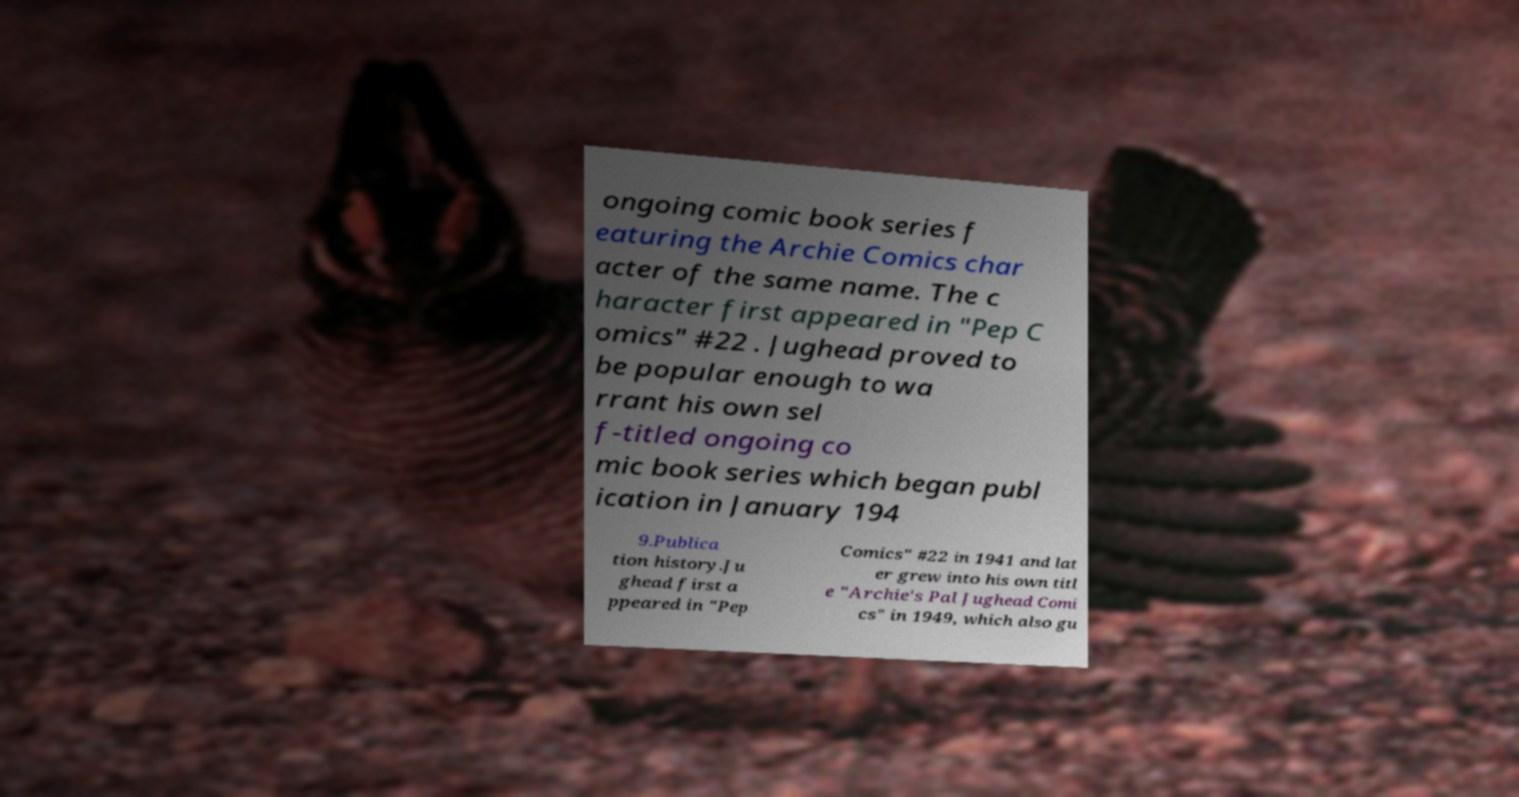Please identify and transcribe the text found in this image. ongoing comic book series f eaturing the Archie Comics char acter of the same name. The c haracter first appeared in "Pep C omics" #22 . Jughead proved to be popular enough to wa rrant his own sel f-titled ongoing co mic book series which began publ ication in January 194 9.Publica tion history.Ju ghead first a ppeared in "Pep Comics" #22 in 1941 and lat er grew into his own titl e "Archie's Pal Jughead Comi cs" in 1949, which also gu 